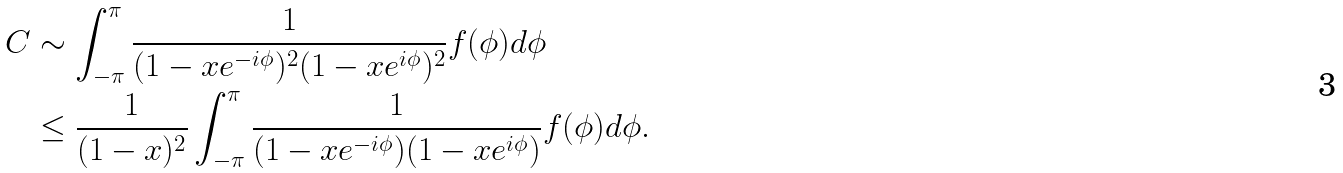<formula> <loc_0><loc_0><loc_500><loc_500>C & \sim \int _ { - \pi } ^ { \pi } \frac { 1 } { ( 1 - x e ^ { - i \phi } ) ^ { 2 } ( 1 - x e ^ { i \phi } ) ^ { 2 } } f ( \phi ) d \phi \\ & \leq \frac { 1 } { ( 1 - x ) ^ { 2 } } \int _ { - \pi } ^ { \pi } \frac { 1 } { ( 1 - x e ^ { - i \phi } ) ( 1 - x e ^ { i \phi } ) } f ( \phi ) d \phi . \\</formula> 